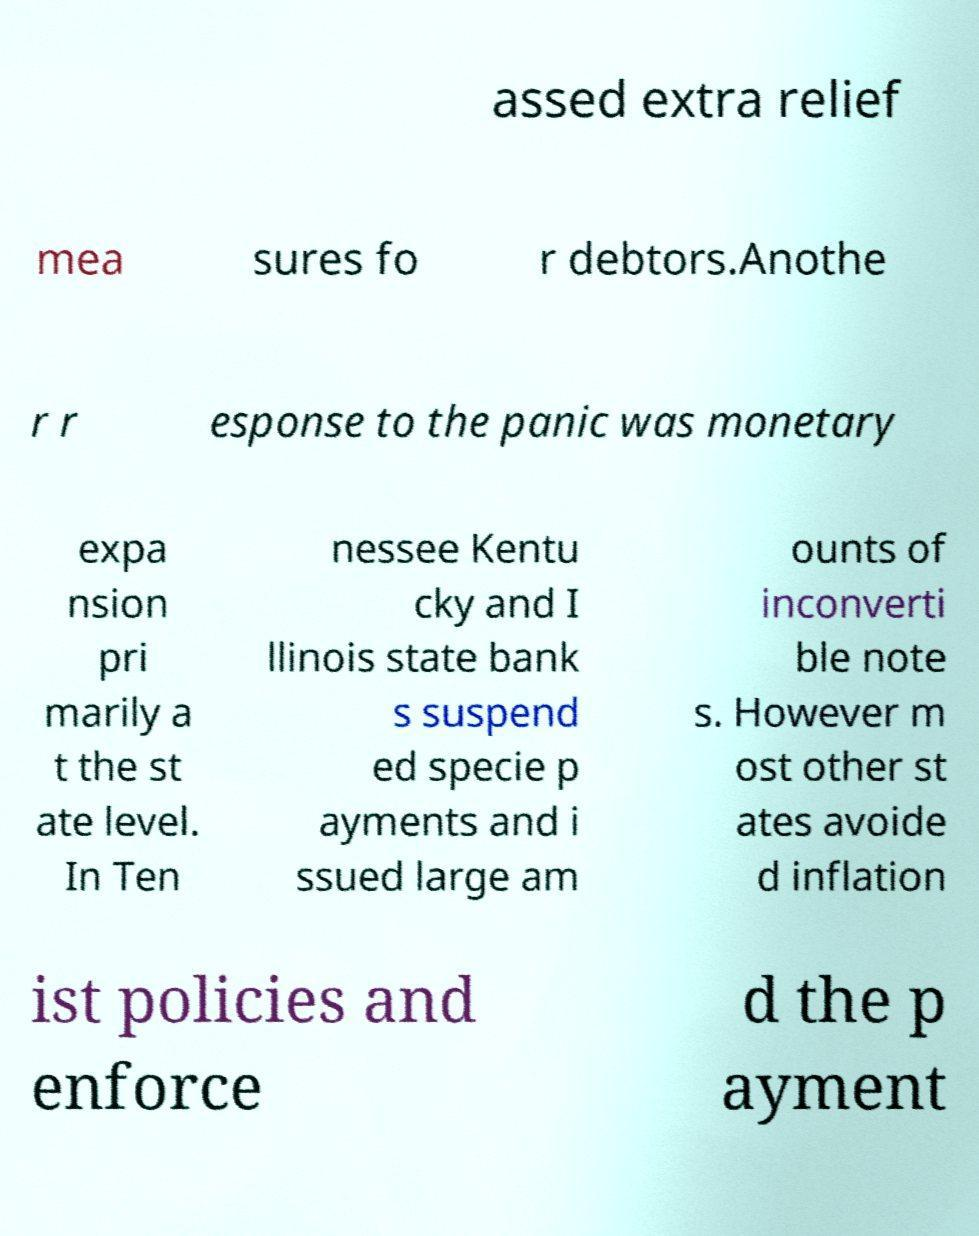Can you accurately transcribe the text from the provided image for me? assed extra relief mea sures fo r debtors.Anothe r r esponse to the panic was monetary expa nsion pri marily a t the st ate level. In Ten nessee Kentu cky and I llinois state bank s suspend ed specie p ayments and i ssued large am ounts of inconverti ble note s. However m ost other st ates avoide d inflation ist policies and enforce d the p ayment 